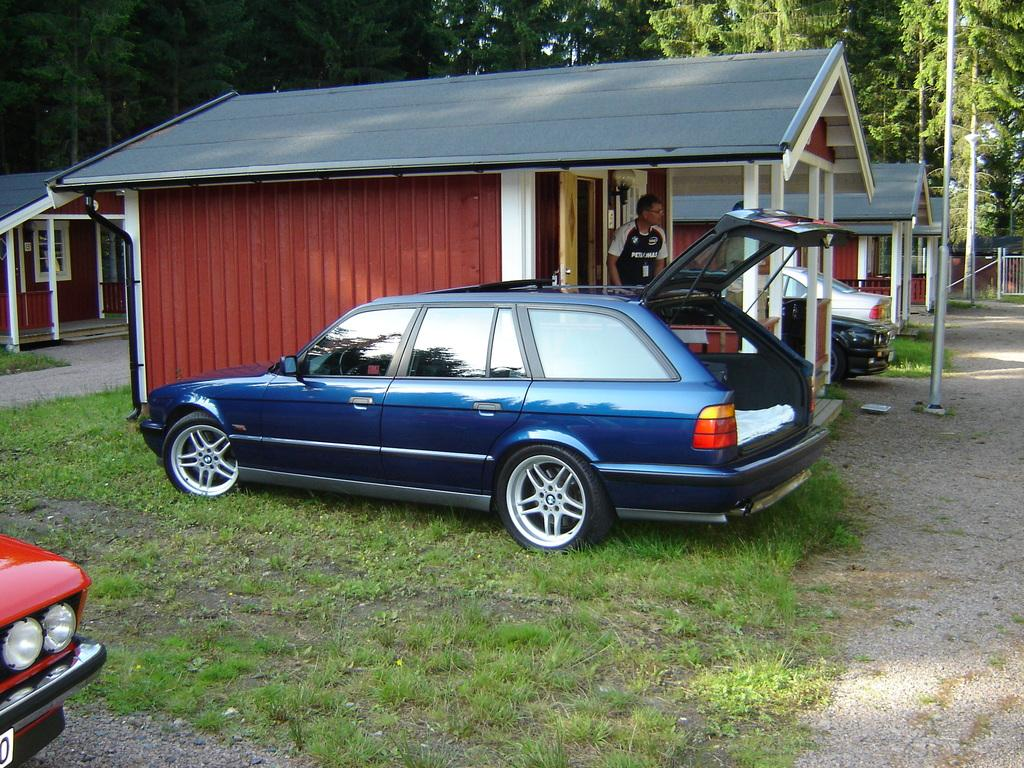What type of structures can be seen in the image? There are houses in the image. Can you describe the person in the image? There is a person standing on the floor in the image. What are the vehicles visible in the image? There are cars parked on the ground in the image. What type of vegetation is present in the image? There are trees and grass in the image. What is the tall, vertical object in the image? There is a pole in the image. How many jellyfish are swimming in the image? There are no jellyfish present in the image; it features houses, a person, cars, trees, grass, and a pole. What type of respect is shown by the person in the image? There is no indication of respect being shown in the image, as it focuses on the physical surroundings and objects. 